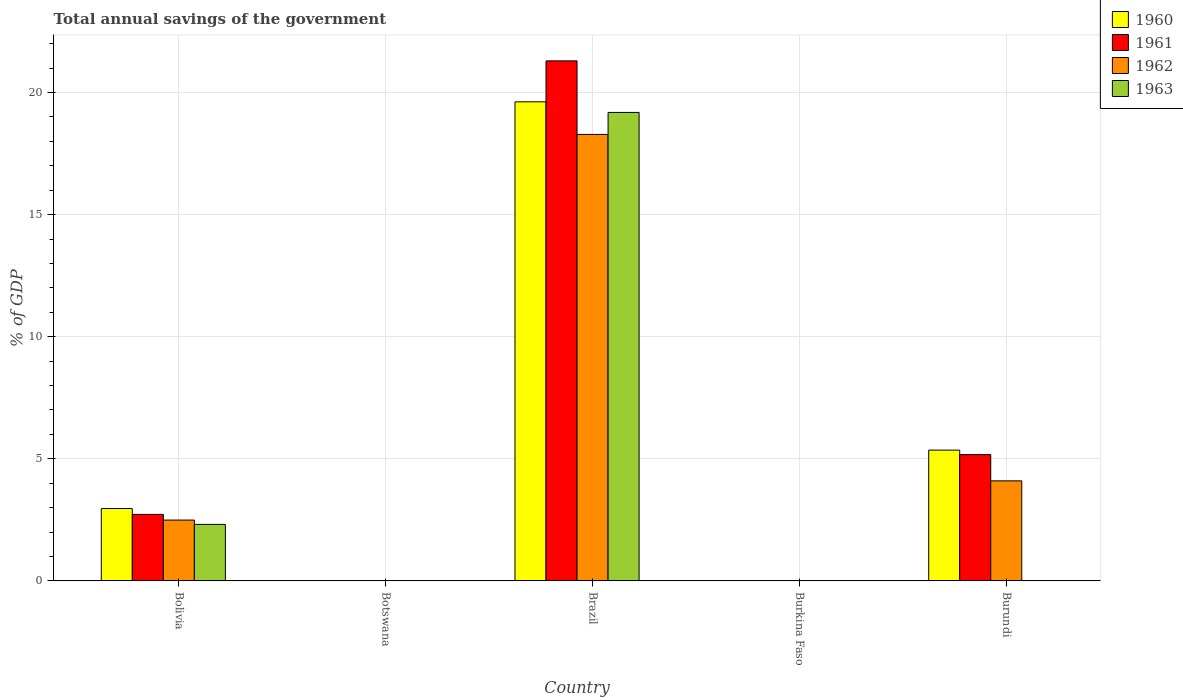How many different coloured bars are there?
Provide a short and direct response. 4. Are the number of bars on each tick of the X-axis equal?
Provide a short and direct response. No. How many bars are there on the 3rd tick from the right?
Your answer should be very brief. 4. What is the label of the 2nd group of bars from the left?
Offer a very short reply. Botswana. What is the total annual savings of the government in 1960 in Burkina Faso?
Provide a short and direct response. 0. Across all countries, what is the maximum total annual savings of the government in 1962?
Make the answer very short. 18.28. Across all countries, what is the minimum total annual savings of the government in 1960?
Ensure brevity in your answer.  0. What is the total total annual savings of the government in 1960 in the graph?
Keep it short and to the point. 27.94. What is the difference between the total annual savings of the government in 1962 in Brazil and that in Burundi?
Keep it short and to the point. 14.19. What is the difference between the total annual savings of the government in 1960 in Botswana and the total annual savings of the government in 1962 in Bolivia?
Ensure brevity in your answer.  -2.49. What is the average total annual savings of the government in 1960 per country?
Offer a very short reply. 5.59. What is the difference between the total annual savings of the government of/in 1960 and total annual savings of the government of/in 1962 in Brazil?
Offer a very short reply. 1.34. In how many countries, is the total annual savings of the government in 1961 greater than 6 %?
Keep it short and to the point. 1. What is the ratio of the total annual savings of the government in 1962 in Brazil to that in Burundi?
Offer a terse response. 4.46. Is the difference between the total annual savings of the government in 1960 in Bolivia and Brazil greater than the difference between the total annual savings of the government in 1962 in Bolivia and Brazil?
Offer a terse response. No. What is the difference between the highest and the second highest total annual savings of the government in 1960?
Offer a very short reply. -16.66. What is the difference between the highest and the lowest total annual savings of the government in 1962?
Offer a very short reply. 18.28. How many bars are there?
Your answer should be compact. 11. Are all the bars in the graph horizontal?
Ensure brevity in your answer.  No. How many countries are there in the graph?
Make the answer very short. 5. Are the values on the major ticks of Y-axis written in scientific E-notation?
Offer a very short reply. No. Does the graph contain any zero values?
Give a very brief answer. Yes. Where does the legend appear in the graph?
Offer a very short reply. Top right. What is the title of the graph?
Your response must be concise. Total annual savings of the government. Does "2000" appear as one of the legend labels in the graph?
Make the answer very short. No. What is the label or title of the Y-axis?
Make the answer very short. % of GDP. What is the % of GDP of 1960 in Bolivia?
Your answer should be compact. 2.96. What is the % of GDP in 1961 in Bolivia?
Your answer should be very brief. 2.73. What is the % of GDP of 1962 in Bolivia?
Make the answer very short. 2.49. What is the % of GDP of 1963 in Bolivia?
Ensure brevity in your answer.  2.32. What is the % of GDP in 1960 in Botswana?
Your answer should be very brief. 0. What is the % of GDP of 1960 in Brazil?
Make the answer very short. 19.62. What is the % of GDP of 1961 in Brazil?
Ensure brevity in your answer.  21.3. What is the % of GDP in 1962 in Brazil?
Offer a terse response. 18.28. What is the % of GDP of 1963 in Brazil?
Provide a short and direct response. 19.19. What is the % of GDP in 1960 in Burkina Faso?
Your answer should be very brief. 0. What is the % of GDP of 1961 in Burkina Faso?
Provide a short and direct response. 0. What is the % of GDP of 1962 in Burkina Faso?
Your response must be concise. 0. What is the % of GDP of 1960 in Burundi?
Your answer should be compact. 5.36. What is the % of GDP of 1961 in Burundi?
Give a very brief answer. 5.17. What is the % of GDP in 1962 in Burundi?
Your response must be concise. 4.1. Across all countries, what is the maximum % of GDP in 1960?
Your answer should be compact. 19.62. Across all countries, what is the maximum % of GDP of 1961?
Provide a short and direct response. 21.3. Across all countries, what is the maximum % of GDP of 1962?
Offer a very short reply. 18.28. Across all countries, what is the maximum % of GDP of 1963?
Ensure brevity in your answer.  19.19. Across all countries, what is the minimum % of GDP of 1961?
Provide a short and direct response. 0. Across all countries, what is the minimum % of GDP in 1963?
Give a very brief answer. 0. What is the total % of GDP of 1960 in the graph?
Your answer should be very brief. 27.94. What is the total % of GDP in 1961 in the graph?
Provide a short and direct response. 29.19. What is the total % of GDP in 1962 in the graph?
Provide a short and direct response. 24.88. What is the total % of GDP in 1963 in the graph?
Offer a terse response. 21.5. What is the difference between the % of GDP in 1960 in Bolivia and that in Brazil?
Keep it short and to the point. -16.66. What is the difference between the % of GDP of 1961 in Bolivia and that in Brazil?
Your answer should be compact. -18.57. What is the difference between the % of GDP in 1962 in Bolivia and that in Brazil?
Make the answer very short. -15.79. What is the difference between the % of GDP of 1963 in Bolivia and that in Brazil?
Ensure brevity in your answer.  -16.87. What is the difference between the % of GDP of 1960 in Bolivia and that in Burundi?
Provide a succinct answer. -2.39. What is the difference between the % of GDP in 1961 in Bolivia and that in Burundi?
Your response must be concise. -2.45. What is the difference between the % of GDP in 1962 in Bolivia and that in Burundi?
Provide a succinct answer. -1.61. What is the difference between the % of GDP of 1960 in Brazil and that in Burundi?
Keep it short and to the point. 14.26. What is the difference between the % of GDP in 1961 in Brazil and that in Burundi?
Provide a short and direct response. 16.12. What is the difference between the % of GDP in 1962 in Brazil and that in Burundi?
Make the answer very short. 14.19. What is the difference between the % of GDP in 1960 in Bolivia and the % of GDP in 1961 in Brazil?
Provide a short and direct response. -18.33. What is the difference between the % of GDP of 1960 in Bolivia and the % of GDP of 1962 in Brazil?
Keep it short and to the point. -15.32. What is the difference between the % of GDP of 1960 in Bolivia and the % of GDP of 1963 in Brazil?
Offer a terse response. -16.22. What is the difference between the % of GDP of 1961 in Bolivia and the % of GDP of 1962 in Brazil?
Your response must be concise. -15.56. What is the difference between the % of GDP in 1961 in Bolivia and the % of GDP in 1963 in Brazil?
Your answer should be compact. -16.46. What is the difference between the % of GDP in 1962 in Bolivia and the % of GDP in 1963 in Brazil?
Your response must be concise. -16.69. What is the difference between the % of GDP of 1960 in Bolivia and the % of GDP of 1961 in Burundi?
Provide a short and direct response. -2.21. What is the difference between the % of GDP of 1960 in Bolivia and the % of GDP of 1962 in Burundi?
Provide a succinct answer. -1.13. What is the difference between the % of GDP of 1961 in Bolivia and the % of GDP of 1962 in Burundi?
Your response must be concise. -1.37. What is the difference between the % of GDP in 1960 in Brazil and the % of GDP in 1961 in Burundi?
Ensure brevity in your answer.  14.45. What is the difference between the % of GDP in 1960 in Brazil and the % of GDP in 1962 in Burundi?
Offer a terse response. 15.52. What is the difference between the % of GDP in 1961 in Brazil and the % of GDP in 1962 in Burundi?
Offer a terse response. 17.2. What is the average % of GDP in 1960 per country?
Ensure brevity in your answer.  5.59. What is the average % of GDP in 1961 per country?
Provide a succinct answer. 5.84. What is the average % of GDP of 1962 per country?
Your answer should be very brief. 4.98. What is the average % of GDP in 1963 per country?
Ensure brevity in your answer.  4.3. What is the difference between the % of GDP in 1960 and % of GDP in 1961 in Bolivia?
Offer a terse response. 0.24. What is the difference between the % of GDP in 1960 and % of GDP in 1962 in Bolivia?
Ensure brevity in your answer.  0.47. What is the difference between the % of GDP in 1960 and % of GDP in 1963 in Bolivia?
Offer a very short reply. 0.65. What is the difference between the % of GDP of 1961 and % of GDP of 1962 in Bolivia?
Make the answer very short. 0.23. What is the difference between the % of GDP of 1961 and % of GDP of 1963 in Bolivia?
Offer a very short reply. 0.41. What is the difference between the % of GDP in 1962 and % of GDP in 1963 in Bolivia?
Offer a very short reply. 0.18. What is the difference between the % of GDP in 1960 and % of GDP in 1961 in Brazil?
Provide a succinct answer. -1.68. What is the difference between the % of GDP in 1960 and % of GDP in 1962 in Brazil?
Make the answer very short. 1.34. What is the difference between the % of GDP in 1960 and % of GDP in 1963 in Brazil?
Give a very brief answer. 0.43. What is the difference between the % of GDP of 1961 and % of GDP of 1962 in Brazil?
Offer a terse response. 3.01. What is the difference between the % of GDP of 1961 and % of GDP of 1963 in Brazil?
Your response must be concise. 2.11. What is the difference between the % of GDP in 1962 and % of GDP in 1963 in Brazil?
Keep it short and to the point. -0.9. What is the difference between the % of GDP in 1960 and % of GDP in 1961 in Burundi?
Offer a very short reply. 0.18. What is the difference between the % of GDP of 1960 and % of GDP of 1962 in Burundi?
Your response must be concise. 1.26. What is the difference between the % of GDP of 1961 and % of GDP of 1962 in Burundi?
Keep it short and to the point. 1.07. What is the ratio of the % of GDP of 1960 in Bolivia to that in Brazil?
Provide a succinct answer. 0.15. What is the ratio of the % of GDP of 1961 in Bolivia to that in Brazil?
Make the answer very short. 0.13. What is the ratio of the % of GDP in 1962 in Bolivia to that in Brazil?
Your answer should be very brief. 0.14. What is the ratio of the % of GDP of 1963 in Bolivia to that in Brazil?
Keep it short and to the point. 0.12. What is the ratio of the % of GDP of 1960 in Bolivia to that in Burundi?
Offer a terse response. 0.55. What is the ratio of the % of GDP of 1961 in Bolivia to that in Burundi?
Your answer should be very brief. 0.53. What is the ratio of the % of GDP of 1962 in Bolivia to that in Burundi?
Your answer should be very brief. 0.61. What is the ratio of the % of GDP in 1960 in Brazil to that in Burundi?
Offer a very short reply. 3.66. What is the ratio of the % of GDP in 1961 in Brazil to that in Burundi?
Offer a very short reply. 4.12. What is the ratio of the % of GDP in 1962 in Brazil to that in Burundi?
Provide a short and direct response. 4.46. What is the difference between the highest and the second highest % of GDP in 1960?
Keep it short and to the point. 14.26. What is the difference between the highest and the second highest % of GDP in 1961?
Keep it short and to the point. 16.12. What is the difference between the highest and the second highest % of GDP in 1962?
Offer a terse response. 14.19. What is the difference between the highest and the lowest % of GDP in 1960?
Your answer should be very brief. 19.62. What is the difference between the highest and the lowest % of GDP in 1961?
Provide a short and direct response. 21.3. What is the difference between the highest and the lowest % of GDP in 1962?
Make the answer very short. 18.28. What is the difference between the highest and the lowest % of GDP of 1963?
Offer a very short reply. 19.19. 